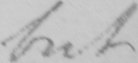What does this handwritten line say? but 